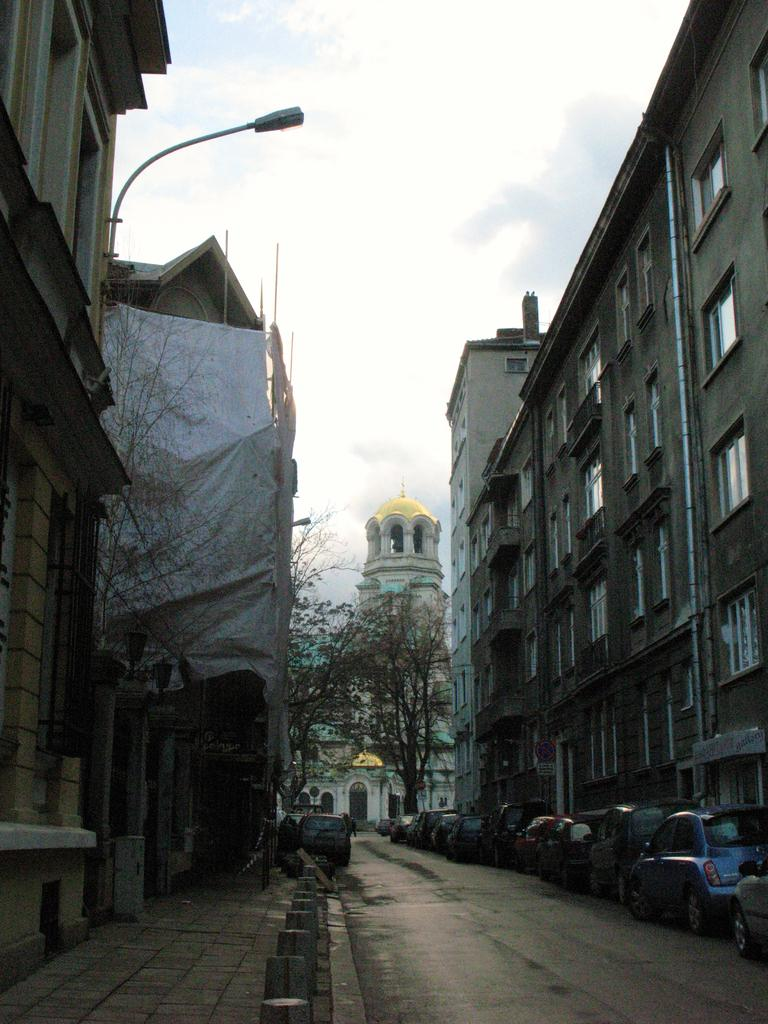What type of vehicles can be seen in the image? There are cars in the image. What natural elements are present in the image? There are trees in the image. What structures can be seen in the image? There are poles, a banner, buildings, and a road in the image. What is visible in the background of the image? The sky is visible in the background of the image. How many beads are hanging from the banner in the image? There are no beads present on the banner in the image. What type of selection process is being used to choose the cars in the image? There is no selection process being depicted in the image; it simply shows cars, trees, poles, a banner, buildings, and a road. 